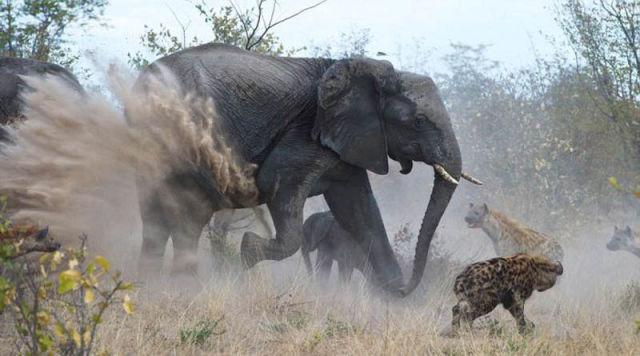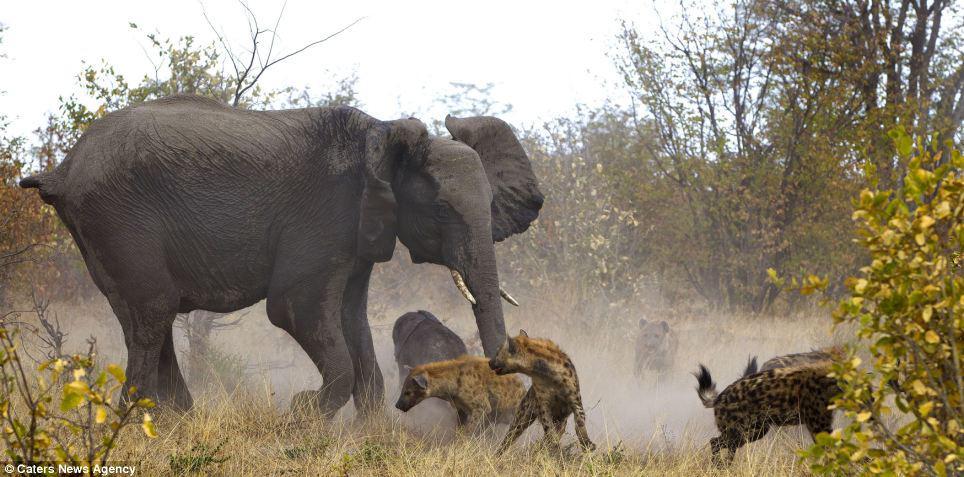The first image is the image on the left, the second image is the image on the right. Considering the images on both sides, is "Each image shows an elephant in a similar forward charging pose near hyenas." valid? Answer yes or no. Yes. The first image is the image on the left, the second image is the image on the right. Given the left and right images, does the statement "In one of the images, there are more than two hyenas crowding the baby elephant." hold true? Answer yes or no. No. 